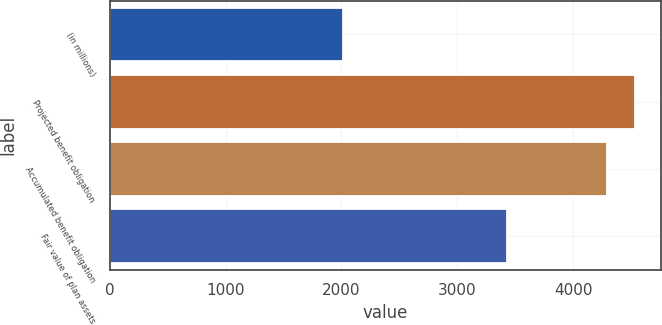Convert chart to OTSL. <chart><loc_0><loc_0><loc_500><loc_500><bar_chart><fcel>(in millions)<fcel>Projected benefit obligation<fcel>Accumulated benefit obligation<fcel>Fair value of plan assets<nl><fcel>2011<fcel>4533.7<fcel>4291<fcel>3432<nl></chart> 